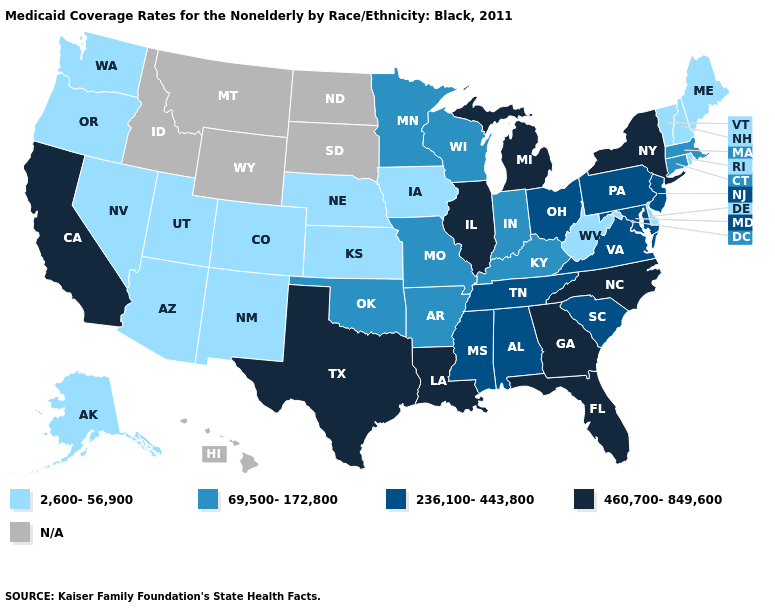Does New York have the highest value in the Northeast?
Give a very brief answer. Yes. Does Nevada have the highest value in the West?
Answer briefly. No. Name the states that have a value in the range 69,500-172,800?
Answer briefly. Arkansas, Connecticut, Indiana, Kentucky, Massachusetts, Minnesota, Missouri, Oklahoma, Wisconsin. Does Florida have the highest value in the South?
Write a very short answer. Yes. Is the legend a continuous bar?
Short answer required. No. Name the states that have a value in the range 460,700-849,600?
Short answer required. California, Florida, Georgia, Illinois, Louisiana, Michigan, New York, North Carolina, Texas. How many symbols are there in the legend?
Short answer required. 5. Does the map have missing data?
Write a very short answer. Yes. Which states hav the highest value in the Northeast?
Answer briefly. New York. What is the highest value in states that border Kansas?
Concise answer only. 69,500-172,800. Name the states that have a value in the range N/A?
Give a very brief answer. Hawaii, Idaho, Montana, North Dakota, South Dakota, Wyoming. What is the value of New Hampshire?
Answer briefly. 2,600-56,900. What is the highest value in the USA?
Give a very brief answer. 460,700-849,600. 